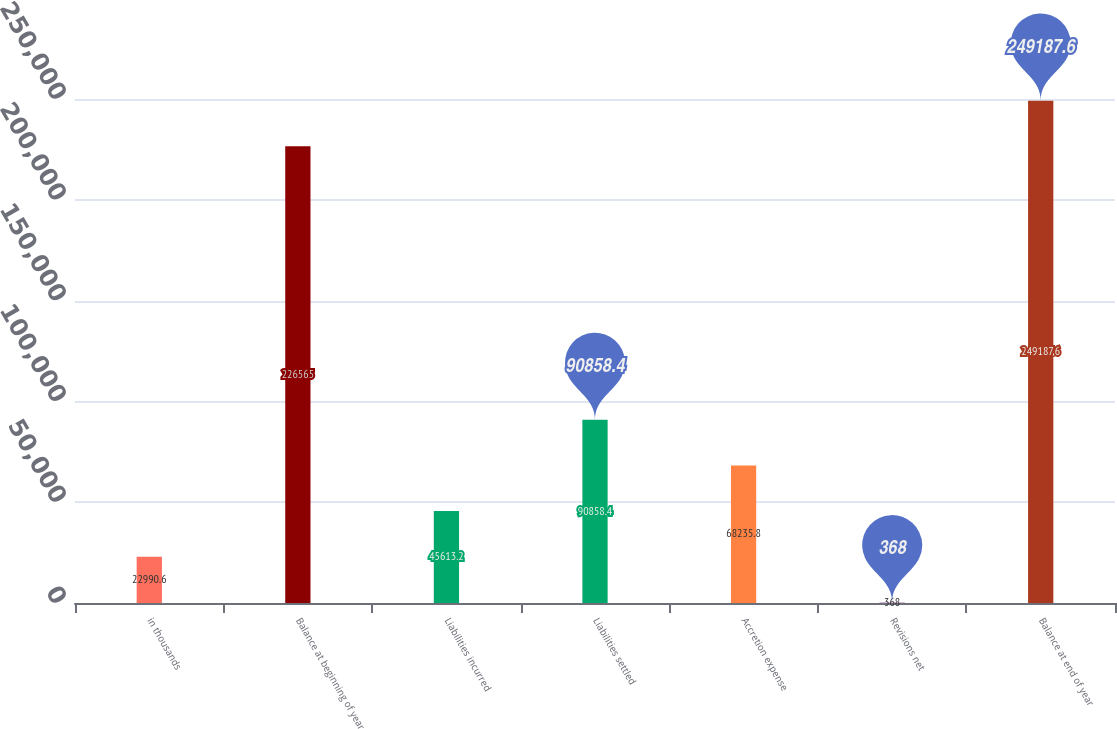Convert chart to OTSL. <chart><loc_0><loc_0><loc_500><loc_500><bar_chart><fcel>in thousands<fcel>Balance at beginning of year<fcel>Liabilities incurred<fcel>Liabilities settled<fcel>Accretion expense<fcel>Revisions net<fcel>Balance at end of year<nl><fcel>22990.6<fcel>226565<fcel>45613.2<fcel>90858.4<fcel>68235.8<fcel>368<fcel>249188<nl></chart> 